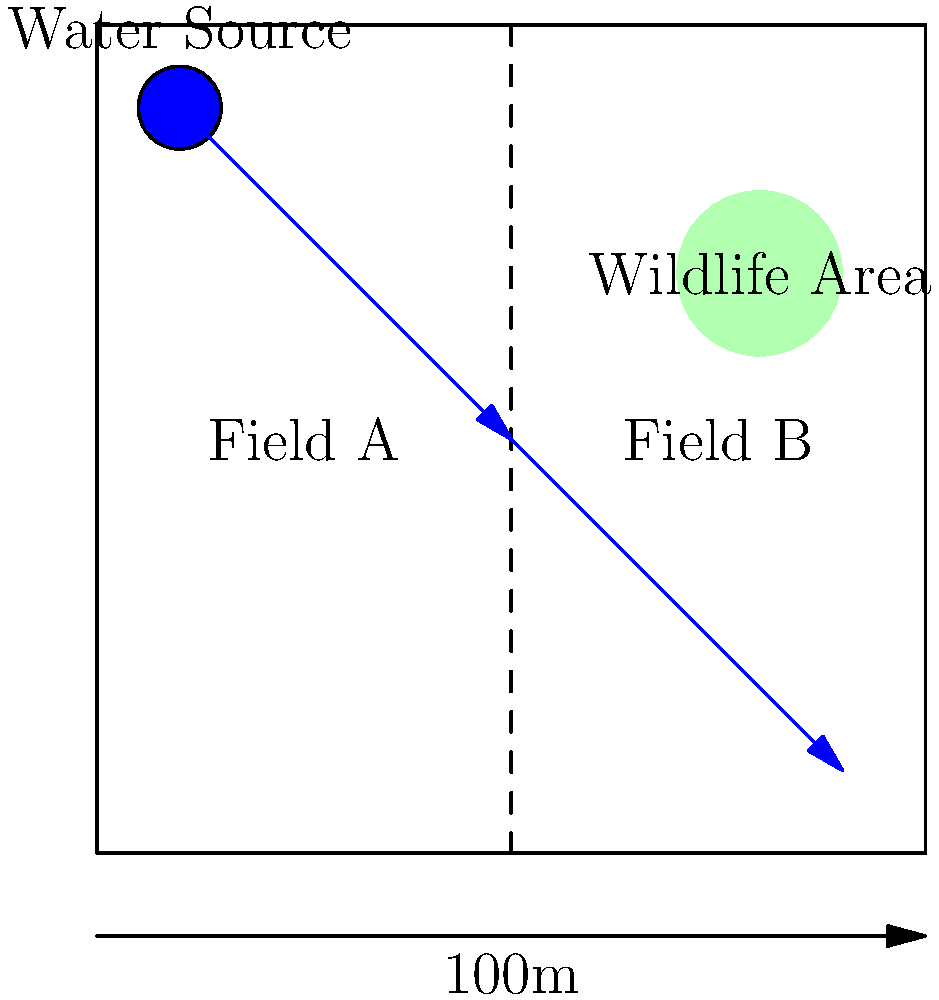Design an efficient irrigation system for the given field layout that minimizes impact on the local water source and respects the wildlife area. Calculate the total length of piping needed if the main pipe runs from the water source to point (50,50) and then to point (90,10). Round your answer to the nearest meter. To solve this problem, we need to follow these steps:

1. Identify the key points:
   - Water source: (10,90)
   - Midpoint: (50,50)
   - End point: (90,10)

2. Calculate the length of the first pipe segment:
   Distance from (10,90) to (50,50)
   $$d_1 = \sqrt{(50-10)^2 + (50-90)^2} = \sqrt{40^2 + (-40)^2} = \sqrt{3200} \approx 56.57 \text{ m}$$

3. Calculate the length of the second pipe segment:
   Distance from (50,50) to (90,10)
   $$d_2 = \sqrt{(90-50)^2 + (10-50)^2} = \sqrt{40^2 + (-40)^2} = \sqrt{3200} \approx 56.57 \text{ m}$$

4. Sum up the total length of piping:
   $$\text{Total length} = d_1 + d_2 = 56.57 + 56.57 = 113.14 \text{ m}$$

5. Round to the nearest meter:
   113.14 m rounds to 113 m

This design is efficient because:
- It uses the shortest path to connect the water source to both fields.
- It avoids the wildlife area, minimizing environmental impact.
- The single main pipe with a branch point reduces material usage and potential water loss.
Answer: 113 m 